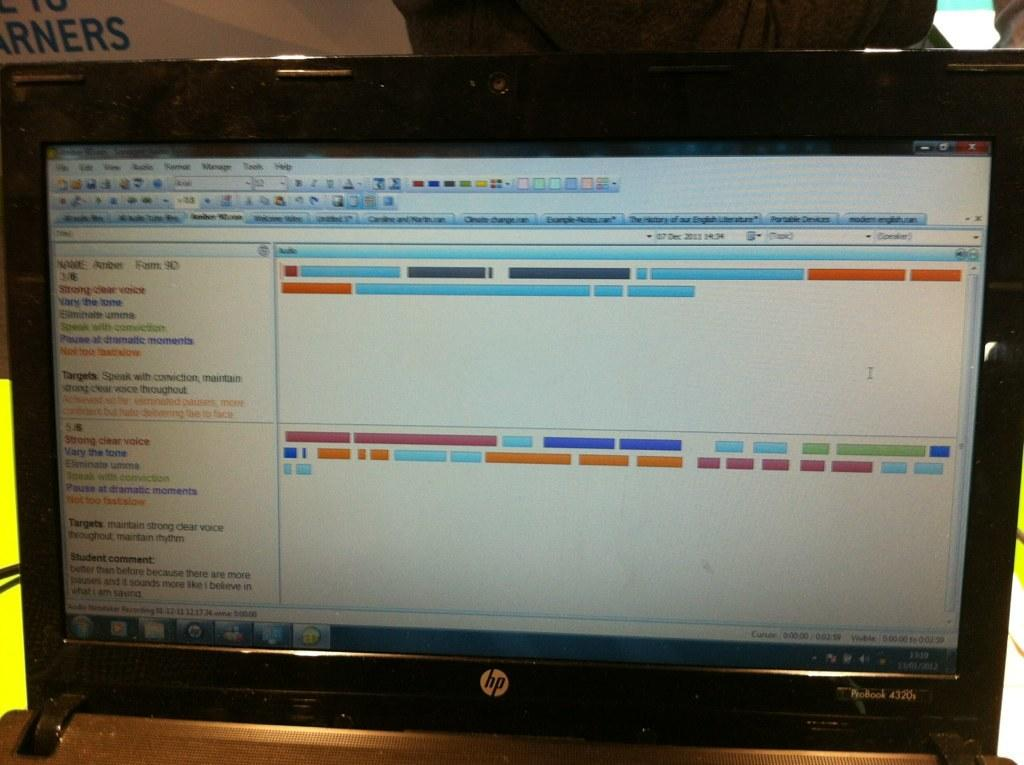<image>
Summarize the visual content of the image. HP laptop screen that says "Strong Clear Voice" on the left. 